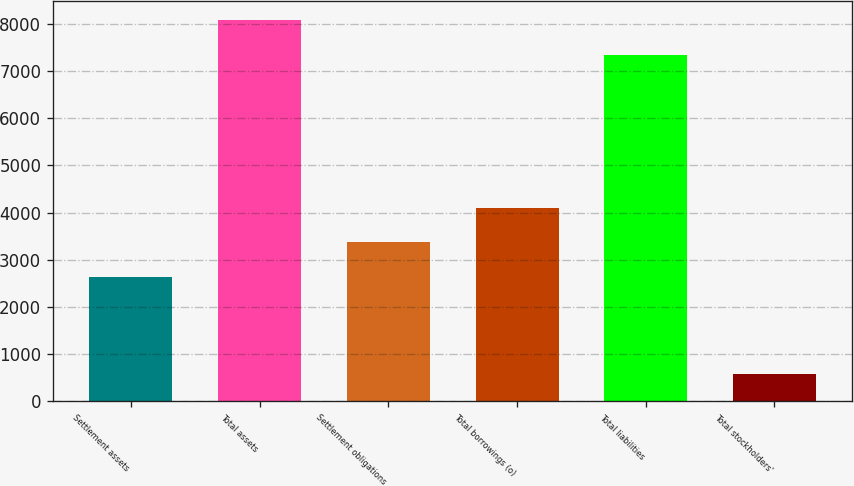Convert chart. <chart><loc_0><loc_0><loc_500><loc_500><bar_chart><fcel>Settlement assets<fcel>Total assets<fcel>Settlement obligations<fcel>Total borrowings (o)<fcel>Total liabilities<fcel>Total stockholders'<nl><fcel>2635.2<fcel>8081.15<fcel>3369.85<fcel>4104.5<fcel>7346.5<fcel>582.7<nl></chart> 